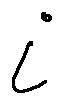<formula> <loc_0><loc_0><loc_500><loc_500>i</formula> 